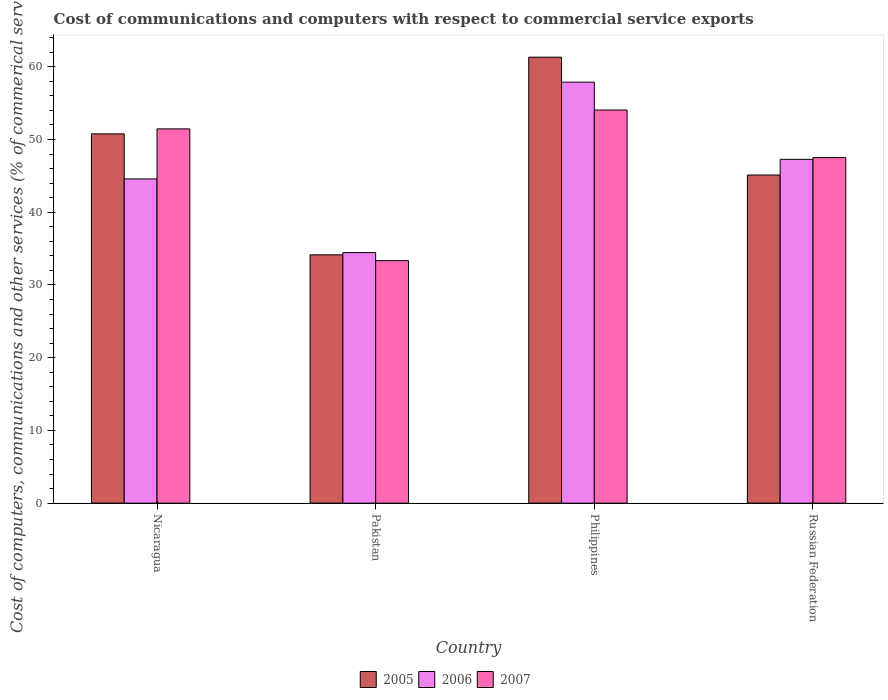Are the number of bars per tick equal to the number of legend labels?
Offer a terse response. Yes. Are the number of bars on each tick of the X-axis equal?
Give a very brief answer. Yes. How many bars are there on the 4th tick from the left?
Give a very brief answer. 3. What is the label of the 1st group of bars from the left?
Ensure brevity in your answer.  Nicaragua. In how many cases, is the number of bars for a given country not equal to the number of legend labels?
Your answer should be compact. 0. What is the cost of communications and computers in 2006 in Nicaragua?
Make the answer very short. 44.58. Across all countries, what is the maximum cost of communications and computers in 2005?
Give a very brief answer. 61.31. Across all countries, what is the minimum cost of communications and computers in 2005?
Offer a very short reply. 34.14. What is the total cost of communications and computers in 2005 in the graph?
Offer a very short reply. 191.33. What is the difference between the cost of communications and computers in 2005 in Nicaragua and that in Russian Federation?
Give a very brief answer. 5.66. What is the difference between the cost of communications and computers in 2005 in Philippines and the cost of communications and computers in 2006 in Pakistan?
Provide a short and direct response. 26.87. What is the average cost of communications and computers in 2005 per country?
Your response must be concise. 47.83. What is the difference between the cost of communications and computers of/in 2007 and cost of communications and computers of/in 2005 in Russian Federation?
Keep it short and to the point. 2.39. In how many countries, is the cost of communications and computers in 2006 greater than 30 %?
Ensure brevity in your answer.  4. What is the ratio of the cost of communications and computers in 2005 in Philippines to that in Russian Federation?
Your response must be concise. 1.36. Is the cost of communications and computers in 2005 in Nicaragua less than that in Philippines?
Keep it short and to the point. Yes. Is the difference between the cost of communications and computers in 2007 in Nicaragua and Philippines greater than the difference between the cost of communications and computers in 2005 in Nicaragua and Philippines?
Offer a terse response. Yes. What is the difference between the highest and the second highest cost of communications and computers in 2006?
Make the answer very short. 13.31. What is the difference between the highest and the lowest cost of communications and computers in 2007?
Provide a succinct answer. 20.71. In how many countries, is the cost of communications and computers in 2005 greater than the average cost of communications and computers in 2005 taken over all countries?
Your answer should be compact. 2. Are all the bars in the graph horizontal?
Keep it short and to the point. No. How many countries are there in the graph?
Your response must be concise. 4. Does the graph contain any zero values?
Provide a succinct answer. No. What is the title of the graph?
Your answer should be very brief. Cost of communications and computers with respect to commercial service exports. Does "1965" appear as one of the legend labels in the graph?
Make the answer very short. No. What is the label or title of the Y-axis?
Keep it short and to the point. Cost of computers, communications and other services (% of commerical service exports). What is the Cost of computers, communications and other services (% of commerical service exports) of 2005 in Nicaragua?
Offer a very short reply. 50.77. What is the Cost of computers, communications and other services (% of commerical service exports) of 2006 in Nicaragua?
Make the answer very short. 44.58. What is the Cost of computers, communications and other services (% of commerical service exports) in 2007 in Nicaragua?
Make the answer very short. 51.46. What is the Cost of computers, communications and other services (% of commerical service exports) of 2005 in Pakistan?
Give a very brief answer. 34.14. What is the Cost of computers, communications and other services (% of commerical service exports) of 2006 in Pakistan?
Keep it short and to the point. 34.45. What is the Cost of computers, communications and other services (% of commerical service exports) of 2007 in Pakistan?
Give a very brief answer. 33.34. What is the Cost of computers, communications and other services (% of commerical service exports) of 2005 in Philippines?
Keep it short and to the point. 61.31. What is the Cost of computers, communications and other services (% of commerical service exports) in 2006 in Philippines?
Give a very brief answer. 57.88. What is the Cost of computers, communications and other services (% of commerical service exports) of 2007 in Philippines?
Offer a very short reply. 54.05. What is the Cost of computers, communications and other services (% of commerical service exports) of 2005 in Russian Federation?
Make the answer very short. 45.11. What is the Cost of computers, communications and other services (% of commerical service exports) in 2006 in Russian Federation?
Your response must be concise. 47.27. What is the Cost of computers, communications and other services (% of commerical service exports) of 2007 in Russian Federation?
Your answer should be very brief. 47.5. Across all countries, what is the maximum Cost of computers, communications and other services (% of commerical service exports) of 2005?
Give a very brief answer. 61.31. Across all countries, what is the maximum Cost of computers, communications and other services (% of commerical service exports) in 2006?
Your answer should be very brief. 57.88. Across all countries, what is the maximum Cost of computers, communications and other services (% of commerical service exports) of 2007?
Keep it short and to the point. 54.05. Across all countries, what is the minimum Cost of computers, communications and other services (% of commerical service exports) of 2005?
Offer a terse response. 34.14. Across all countries, what is the minimum Cost of computers, communications and other services (% of commerical service exports) in 2006?
Keep it short and to the point. 34.45. Across all countries, what is the minimum Cost of computers, communications and other services (% of commerical service exports) in 2007?
Give a very brief answer. 33.34. What is the total Cost of computers, communications and other services (% of commerical service exports) of 2005 in the graph?
Your response must be concise. 191.33. What is the total Cost of computers, communications and other services (% of commerical service exports) of 2006 in the graph?
Your answer should be compact. 184.17. What is the total Cost of computers, communications and other services (% of commerical service exports) in 2007 in the graph?
Provide a short and direct response. 186.35. What is the difference between the Cost of computers, communications and other services (% of commerical service exports) of 2005 in Nicaragua and that in Pakistan?
Keep it short and to the point. 16.63. What is the difference between the Cost of computers, communications and other services (% of commerical service exports) of 2006 in Nicaragua and that in Pakistan?
Ensure brevity in your answer.  10.13. What is the difference between the Cost of computers, communications and other services (% of commerical service exports) of 2007 in Nicaragua and that in Pakistan?
Offer a terse response. 18.12. What is the difference between the Cost of computers, communications and other services (% of commerical service exports) in 2005 in Nicaragua and that in Philippines?
Your answer should be very brief. -10.54. What is the difference between the Cost of computers, communications and other services (% of commerical service exports) of 2006 in Nicaragua and that in Philippines?
Offer a terse response. -13.31. What is the difference between the Cost of computers, communications and other services (% of commerical service exports) in 2007 in Nicaragua and that in Philippines?
Provide a succinct answer. -2.59. What is the difference between the Cost of computers, communications and other services (% of commerical service exports) in 2005 in Nicaragua and that in Russian Federation?
Give a very brief answer. 5.66. What is the difference between the Cost of computers, communications and other services (% of commerical service exports) of 2006 in Nicaragua and that in Russian Federation?
Provide a short and direct response. -2.69. What is the difference between the Cost of computers, communications and other services (% of commerical service exports) of 2007 in Nicaragua and that in Russian Federation?
Your answer should be compact. 3.95. What is the difference between the Cost of computers, communications and other services (% of commerical service exports) of 2005 in Pakistan and that in Philippines?
Your answer should be compact. -27.18. What is the difference between the Cost of computers, communications and other services (% of commerical service exports) in 2006 in Pakistan and that in Philippines?
Ensure brevity in your answer.  -23.43. What is the difference between the Cost of computers, communications and other services (% of commerical service exports) in 2007 in Pakistan and that in Philippines?
Your answer should be compact. -20.71. What is the difference between the Cost of computers, communications and other services (% of commerical service exports) of 2005 in Pakistan and that in Russian Federation?
Give a very brief answer. -10.97. What is the difference between the Cost of computers, communications and other services (% of commerical service exports) in 2006 in Pakistan and that in Russian Federation?
Offer a very short reply. -12.82. What is the difference between the Cost of computers, communications and other services (% of commerical service exports) in 2007 in Pakistan and that in Russian Federation?
Provide a succinct answer. -14.17. What is the difference between the Cost of computers, communications and other services (% of commerical service exports) of 2005 in Philippines and that in Russian Federation?
Your answer should be compact. 16.2. What is the difference between the Cost of computers, communications and other services (% of commerical service exports) in 2006 in Philippines and that in Russian Federation?
Give a very brief answer. 10.62. What is the difference between the Cost of computers, communications and other services (% of commerical service exports) in 2007 in Philippines and that in Russian Federation?
Keep it short and to the point. 6.54. What is the difference between the Cost of computers, communications and other services (% of commerical service exports) of 2005 in Nicaragua and the Cost of computers, communications and other services (% of commerical service exports) of 2006 in Pakistan?
Make the answer very short. 16.32. What is the difference between the Cost of computers, communications and other services (% of commerical service exports) of 2005 in Nicaragua and the Cost of computers, communications and other services (% of commerical service exports) of 2007 in Pakistan?
Your answer should be very brief. 17.43. What is the difference between the Cost of computers, communications and other services (% of commerical service exports) of 2006 in Nicaragua and the Cost of computers, communications and other services (% of commerical service exports) of 2007 in Pakistan?
Make the answer very short. 11.24. What is the difference between the Cost of computers, communications and other services (% of commerical service exports) of 2005 in Nicaragua and the Cost of computers, communications and other services (% of commerical service exports) of 2006 in Philippines?
Your answer should be compact. -7.11. What is the difference between the Cost of computers, communications and other services (% of commerical service exports) of 2005 in Nicaragua and the Cost of computers, communications and other services (% of commerical service exports) of 2007 in Philippines?
Your response must be concise. -3.28. What is the difference between the Cost of computers, communications and other services (% of commerical service exports) of 2006 in Nicaragua and the Cost of computers, communications and other services (% of commerical service exports) of 2007 in Philippines?
Provide a succinct answer. -9.47. What is the difference between the Cost of computers, communications and other services (% of commerical service exports) in 2005 in Nicaragua and the Cost of computers, communications and other services (% of commerical service exports) in 2006 in Russian Federation?
Your answer should be compact. 3.5. What is the difference between the Cost of computers, communications and other services (% of commerical service exports) in 2005 in Nicaragua and the Cost of computers, communications and other services (% of commerical service exports) in 2007 in Russian Federation?
Offer a terse response. 3.27. What is the difference between the Cost of computers, communications and other services (% of commerical service exports) of 2006 in Nicaragua and the Cost of computers, communications and other services (% of commerical service exports) of 2007 in Russian Federation?
Offer a very short reply. -2.93. What is the difference between the Cost of computers, communications and other services (% of commerical service exports) in 2005 in Pakistan and the Cost of computers, communications and other services (% of commerical service exports) in 2006 in Philippines?
Provide a succinct answer. -23.74. What is the difference between the Cost of computers, communications and other services (% of commerical service exports) in 2005 in Pakistan and the Cost of computers, communications and other services (% of commerical service exports) in 2007 in Philippines?
Your response must be concise. -19.91. What is the difference between the Cost of computers, communications and other services (% of commerical service exports) of 2006 in Pakistan and the Cost of computers, communications and other services (% of commerical service exports) of 2007 in Philippines?
Give a very brief answer. -19.6. What is the difference between the Cost of computers, communications and other services (% of commerical service exports) of 2005 in Pakistan and the Cost of computers, communications and other services (% of commerical service exports) of 2006 in Russian Federation?
Your answer should be very brief. -13.13. What is the difference between the Cost of computers, communications and other services (% of commerical service exports) of 2005 in Pakistan and the Cost of computers, communications and other services (% of commerical service exports) of 2007 in Russian Federation?
Your answer should be compact. -13.37. What is the difference between the Cost of computers, communications and other services (% of commerical service exports) of 2006 in Pakistan and the Cost of computers, communications and other services (% of commerical service exports) of 2007 in Russian Federation?
Your response must be concise. -13.06. What is the difference between the Cost of computers, communications and other services (% of commerical service exports) of 2005 in Philippines and the Cost of computers, communications and other services (% of commerical service exports) of 2006 in Russian Federation?
Your answer should be very brief. 14.05. What is the difference between the Cost of computers, communications and other services (% of commerical service exports) in 2005 in Philippines and the Cost of computers, communications and other services (% of commerical service exports) in 2007 in Russian Federation?
Your answer should be very brief. 13.81. What is the difference between the Cost of computers, communications and other services (% of commerical service exports) of 2006 in Philippines and the Cost of computers, communications and other services (% of commerical service exports) of 2007 in Russian Federation?
Your answer should be compact. 10.38. What is the average Cost of computers, communications and other services (% of commerical service exports) in 2005 per country?
Offer a very short reply. 47.83. What is the average Cost of computers, communications and other services (% of commerical service exports) of 2006 per country?
Keep it short and to the point. 46.04. What is the average Cost of computers, communications and other services (% of commerical service exports) in 2007 per country?
Your answer should be compact. 46.59. What is the difference between the Cost of computers, communications and other services (% of commerical service exports) of 2005 and Cost of computers, communications and other services (% of commerical service exports) of 2006 in Nicaragua?
Offer a terse response. 6.19. What is the difference between the Cost of computers, communications and other services (% of commerical service exports) of 2005 and Cost of computers, communications and other services (% of commerical service exports) of 2007 in Nicaragua?
Ensure brevity in your answer.  -0.68. What is the difference between the Cost of computers, communications and other services (% of commerical service exports) of 2006 and Cost of computers, communications and other services (% of commerical service exports) of 2007 in Nicaragua?
Make the answer very short. -6.88. What is the difference between the Cost of computers, communications and other services (% of commerical service exports) in 2005 and Cost of computers, communications and other services (% of commerical service exports) in 2006 in Pakistan?
Make the answer very short. -0.31. What is the difference between the Cost of computers, communications and other services (% of commerical service exports) in 2005 and Cost of computers, communications and other services (% of commerical service exports) in 2007 in Pakistan?
Your answer should be very brief. 0.8. What is the difference between the Cost of computers, communications and other services (% of commerical service exports) of 2006 and Cost of computers, communications and other services (% of commerical service exports) of 2007 in Pakistan?
Offer a very short reply. 1.11. What is the difference between the Cost of computers, communications and other services (% of commerical service exports) of 2005 and Cost of computers, communications and other services (% of commerical service exports) of 2006 in Philippines?
Give a very brief answer. 3.43. What is the difference between the Cost of computers, communications and other services (% of commerical service exports) in 2005 and Cost of computers, communications and other services (% of commerical service exports) in 2007 in Philippines?
Your answer should be very brief. 7.27. What is the difference between the Cost of computers, communications and other services (% of commerical service exports) in 2006 and Cost of computers, communications and other services (% of commerical service exports) in 2007 in Philippines?
Your response must be concise. 3.83. What is the difference between the Cost of computers, communications and other services (% of commerical service exports) of 2005 and Cost of computers, communications and other services (% of commerical service exports) of 2006 in Russian Federation?
Give a very brief answer. -2.15. What is the difference between the Cost of computers, communications and other services (% of commerical service exports) of 2005 and Cost of computers, communications and other services (% of commerical service exports) of 2007 in Russian Federation?
Offer a very short reply. -2.39. What is the difference between the Cost of computers, communications and other services (% of commerical service exports) in 2006 and Cost of computers, communications and other services (% of commerical service exports) in 2007 in Russian Federation?
Provide a succinct answer. -0.24. What is the ratio of the Cost of computers, communications and other services (% of commerical service exports) in 2005 in Nicaragua to that in Pakistan?
Give a very brief answer. 1.49. What is the ratio of the Cost of computers, communications and other services (% of commerical service exports) of 2006 in Nicaragua to that in Pakistan?
Your response must be concise. 1.29. What is the ratio of the Cost of computers, communications and other services (% of commerical service exports) in 2007 in Nicaragua to that in Pakistan?
Your response must be concise. 1.54. What is the ratio of the Cost of computers, communications and other services (% of commerical service exports) of 2005 in Nicaragua to that in Philippines?
Your answer should be very brief. 0.83. What is the ratio of the Cost of computers, communications and other services (% of commerical service exports) of 2006 in Nicaragua to that in Philippines?
Make the answer very short. 0.77. What is the ratio of the Cost of computers, communications and other services (% of commerical service exports) in 2005 in Nicaragua to that in Russian Federation?
Your response must be concise. 1.13. What is the ratio of the Cost of computers, communications and other services (% of commerical service exports) in 2006 in Nicaragua to that in Russian Federation?
Your response must be concise. 0.94. What is the ratio of the Cost of computers, communications and other services (% of commerical service exports) in 2007 in Nicaragua to that in Russian Federation?
Your answer should be compact. 1.08. What is the ratio of the Cost of computers, communications and other services (% of commerical service exports) of 2005 in Pakistan to that in Philippines?
Keep it short and to the point. 0.56. What is the ratio of the Cost of computers, communications and other services (% of commerical service exports) in 2006 in Pakistan to that in Philippines?
Offer a terse response. 0.6. What is the ratio of the Cost of computers, communications and other services (% of commerical service exports) of 2007 in Pakistan to that in Philippines?
Keep it short and to the point. 0.62. What is the ratio of the Cost of computers, communications and other services (% of commerical service exports) of 2005 in Pakistan to that in Russian Federation?
Your answer should be very brief. 0.76. What is the ratio of the Cost of computers, communications and other services (% of commerical service exports) in 2006 in Pakistan to that in Russian Federation?
Your answer should be compact. 0.73. What is the ratio of the Cost of computers, communications and other services (% of commerical service exports) in 2007 in Pakistan to that in Russian Federation?
Keep it short and to the point. 0.7. What is the ratio of the Cost of computers, communications and other services (% of commerical service exports) in 2005 in Philippines to that in Russian Federation?
Provide a short and direct response. 1.36. What is the ratio of the Cost of computers, communications and other services (% of commerical service exports) of 2006 in Philippines to that in Russian Federation?
Offer a terse response. 1.22. What is the ratio of the Cost of computers, communications and other services (% of commerical service exports) in 2007 in Philippines to that in Russian Federation?
Your answer should be compact. 1.14. What is the difference between the highest and the second highest Cost of computers, communications and other services (% of commerical service exports) of 2005?
Your answer should be compact. 10.54. What is the difference between the highest and the second highest Cost of computers, communications and other services (% of commerical service exports) of 2006?
Provide a short and direct response. 10.62. What is the difference between the highest and the second highest Cost of computers, communications and other services (% of commerical service exports) of 2007?
Make the answer very short. 2.59. What is the difference between the highest and the lowest Cost of computers, communications and other services (% of commerical service exports) in 2005?
Offer a very short reply. 27.18. What is the difference between the highest and the lowest Cost of computers, communications and other services (% of commerical service exports) in 2006?
Your response must be concise. 23.43. What is the difference between the highest and the lowest Cost of computers, communications and other services (% of commerical service exports) of 2007?
Keep it short and to the point. 20.71. 